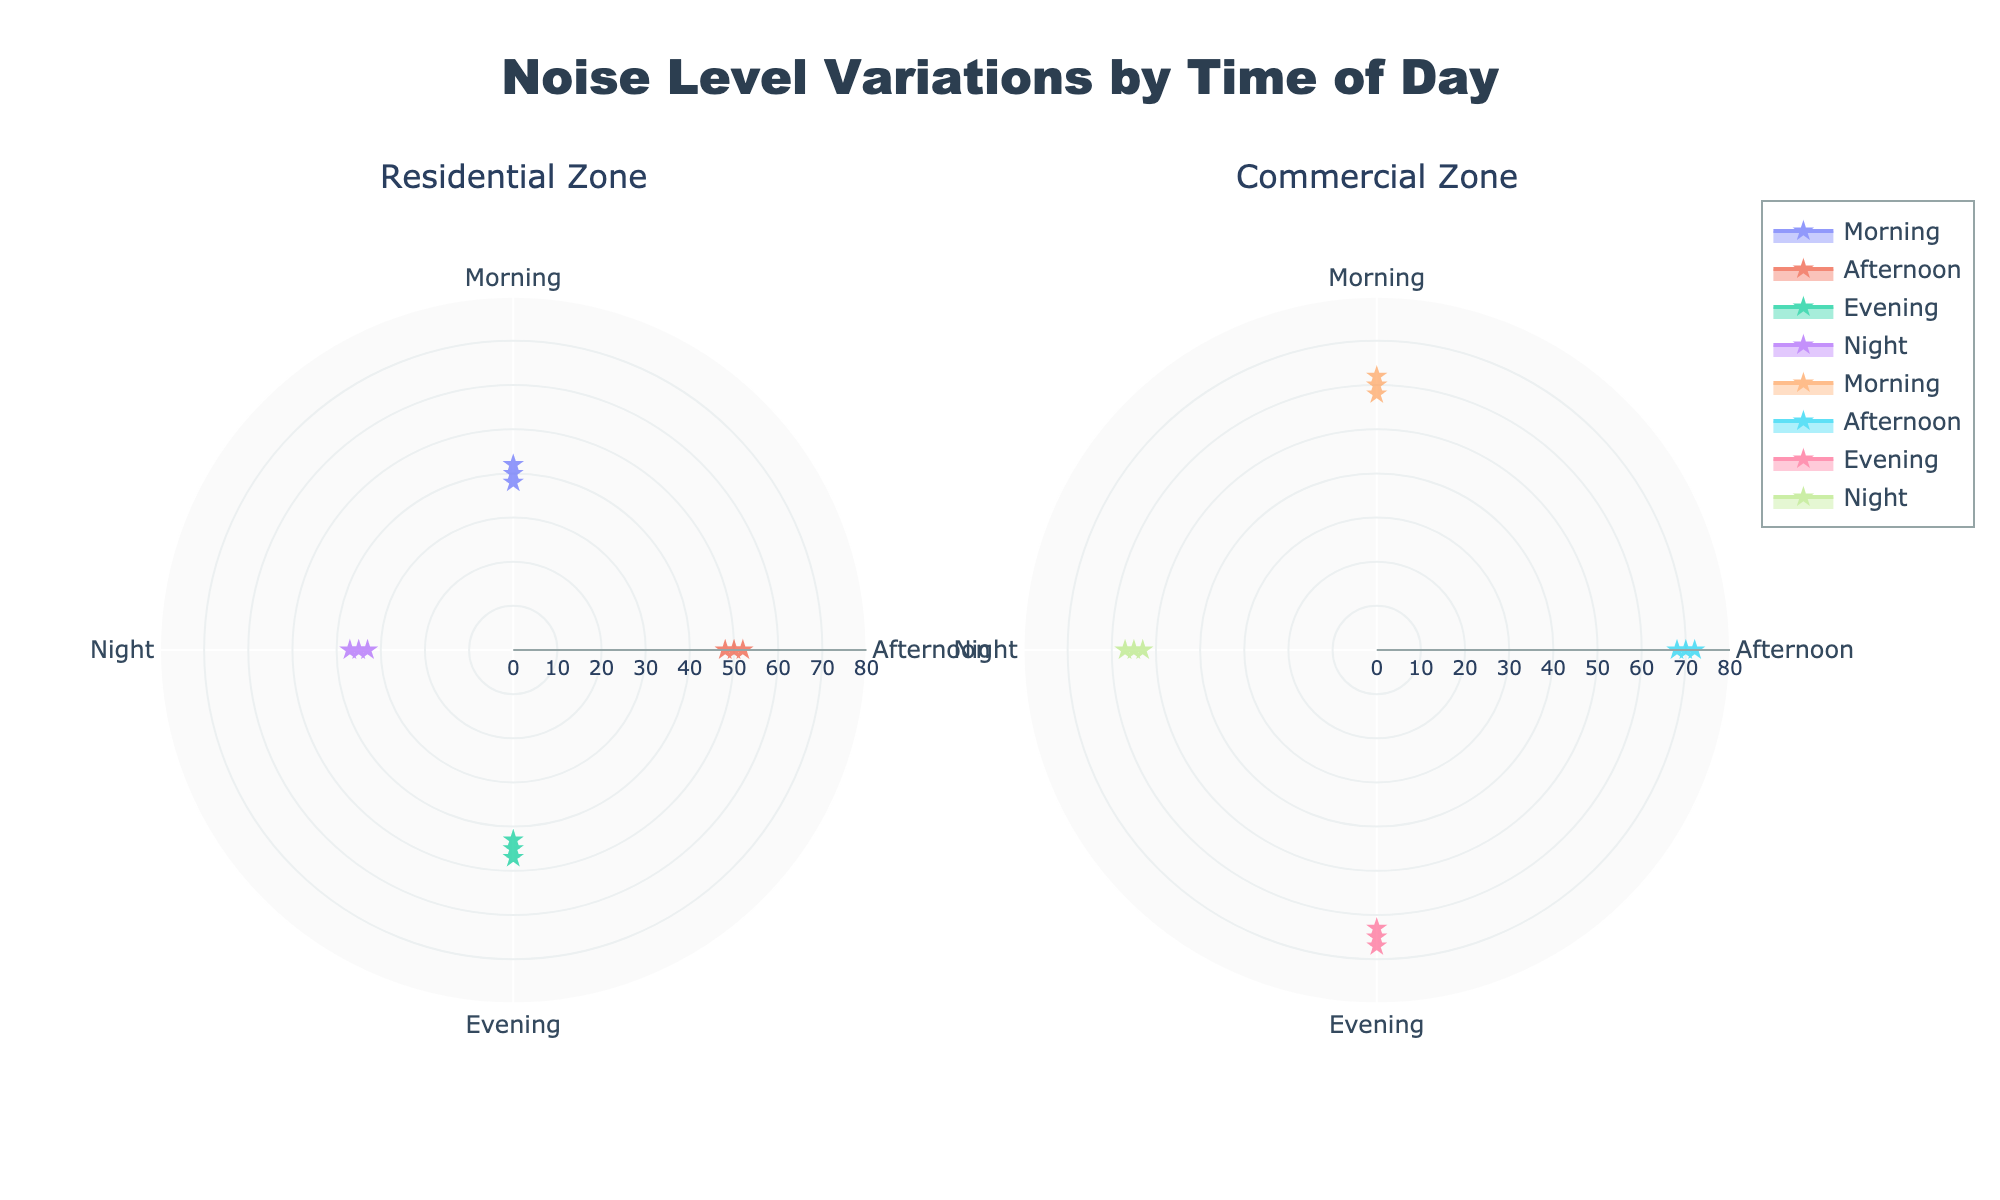What are the peak noise levels during the afternoon in the residential zone? By looking at the residential zone subplot for the afternoon, the peak noise levels are the maximum values of the plotted points. These values are at 50 dB, 52 dB, and 48 dB.
Answer: 52 dB What is the average noise level during the night in the commercial zone? To find the average noise level, sum the values and divide by the number of values. The values are 55 dB, 57 dB, and 53 dB. Adding these up: 55 + 57 + 53 = 165. Dividing by 3, the average is 165 / 3 = 55 dB.
Answer: 55 dB Which zone has a higher variation in noise levels during the evening? To compare variations, we look at the span of noise levels in each subplot. In the residential zone, the spread is from 43 dB to 47 dB. In the commercial zone, the spread is from 63 dB to 67 dB. Thus, both zones have a spread of 4 dB.
Answer: Both zones have the same variation During which time of day does the commercial zone experience the highest noise level? Checking the commercial subplot, the highest noise levels are visible in the afternoon, reaching up to 72 dB.
Answer: Afternoon How do the noise levels in the residential zone during the morning compare to those in the commercial zone? In the residential zone during the morning, noise levels are around 38 to 42 dB. In the commercial zone, the noise levels are significantly higher at 58 to 62 dB.
Answer: Commercial zone is noisier What's the difference between the highest noise levels in the residential and commercial zones during the night? In the residential zone, the highest night noise level is 37 dB. In the commercial zone, it is 57 dB. The difference is 57 - 37 = 20 dB.
Answer: 20 dB What is the overall trend in noise levels from morning to night in both zones? Observing both subplots, noise levels tend to increase from morning to afternoon, decrease slightly in the evening, and reach their lowest levels at night.
Answer: Increase-peak-decrease-lowest What is the mid-range noise level for the commercial zone in the evening? To find the mid-range, average the highest and lowest values. For the commercial zone in the evening: (67 + 63) / 2 = 130 / 2 = 65 dB.
Answer: 65 dB Which time of day has the least noise variation in the residential zone? In the residential subplot, the night has the least variation, with values close to 35, 37, and 33 dB, a span of 4 dB.
Answer: Night 